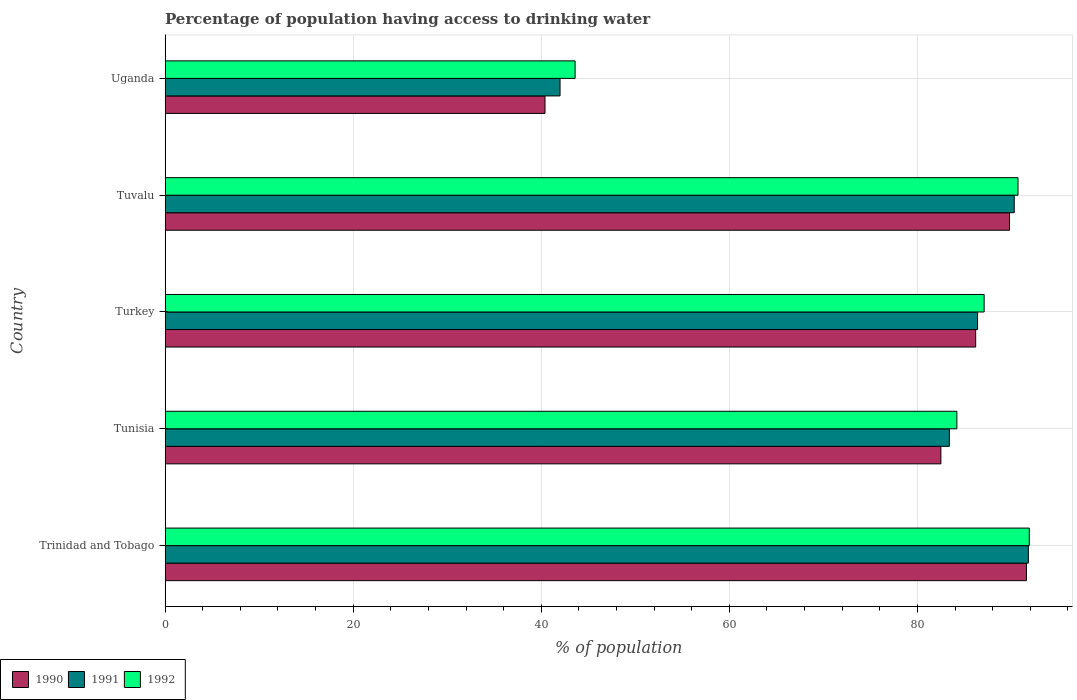How many groups of bars are there?
Give a very brief answer. 5. Are the number of bars on each tick of the Y-axis equal?
Your answer should be compact. Yes. How many bars are there on the 1st tick from the bottom?
Provide a succinct answer. 3. What is the label of the 2nd group of bars from the top?
Offer a terse response. Tuvalu. What is the percentage of population having access to drinking water in 1991 in Trinidad and Tobago?
Your answer should be very brief. 91.8. Across all countries, what is the maximum percentage of population having access to drinking water in 1990?
Your response must be concise. 91.6. In which country was the percentage of population having access to drinking water in 1992 maximum?
Give a very brief answer. Trinidad and Tobago. In which country was the percentage of population having access to drinking water in 1990 minimum?
Your answer should be very brief. Uganda. What is the total percentage of population having access to drinking water in 1992 in the graph?
Offer a very short reply. 397.5. What is the difference between the percentage of population having access to drinking water in 1990 in Tunisia and that in Turkey?
Make the answer very short. -3.7. What is the difference between the percentage of population having access to drinking water in 1990 in Uganda and the percentage of population having access to drinking water in 1992 in Turkey?
Make the answer very short. -46.7. What is the average percentage of population having access to drinking water in 1991 per country?
Give a very brief answer. 78.78. What is the difference between the percentage of population having access to drinking water in 1991 and percentage of population having access to drinking water in 1990 in Tunisia?
Provide a short and direct response. 0.9. In how many countries, is the percentage of population having access to drinking water in 1991 greater than 16 %?
Offer a very short reply. 5. What is the ratio of the percentage of population having access to drinking water in 1990 in Trinidad and Tobago to that in Tuvalu?
Give a very brief answer. 1.02. Is the difference between the percentage of population having access to drinking water in 1991 in Trinidad and Tobago and Uganda greater than the difference between the percentage of population having access to drinking water in 1990 in Trinidad and Tobago and Uganda?
Your response must be concise. No. What is the difference between the highest and the second highest percentage of population having access to drinking water in 1990?
Make the answer very short. 1.8. What is the difference between the highest and the lowest percentage of population having access to drinking water in 1992?
Ensure brevity in your answer.  48.3. In how many countries, is the percentage of population having access to drinking water in 1991 greater than the average percentage of population having access to drinking water in 1991 taken over all countries?
Your response must be concise. 4. How many bars are there?
Keep it short and to the point. 15. Does the graph contain any zero values?
Your answer should be compact. No. Does the graph contain grids?
Your answer should be very brief. Yes. What is the title of the graph?
Your answer should be compact. Percentage of population having access to drinking water. Does "1980" appear as one of the legend labels in the graph?
Your answer should be compact. No. What is the label or title of the X-axis?
Offer a very short reply. % of population. What is the label or title of the Y-axis?
Provide a succinct answer. Country. What is the % of population in 1990 in Trinidad and Tobago?
Ensure brevity in your answer.  91.6. What is the % of population of 1991 in Trinidad and Tobago?
Provide a succinct answer. 91.8. What is the % of population in 1992 in Trinidad and Tobago?
Your response must be concise. 91.9. What is the % of population of 1990 in Tunisia?
Your response must be concise. 82.5. What is the % of population of 1991 in Tunisia?
Offer a terse response. 83.4. What is the % of population in 1992 in Tunisia?
Your answer should be very brief. 84.2. What is the % of population of 1990 in Turkey?
Your answer should be very brief. 86.2. What is the % of population in 1991 in Turkey?
Give a very brief answer. 86.4. What is the % of population of 1992 in Turkey?
Give a very brief answer. 87.1. What is the % of population of 1990 in Tuvalu?
Keep it short and to the point. 89.8. What is the % of population in 1991 in Tuvalu?
Make the answer very short. 90.3. What is the % of population in 1992 in Tuvalu?
Provide a succinct answer. 90.7. What is the % of population in 1990 in Uganda?
Keep it short and to the point. 40.4. What is the % of population in 1991 in Uganda?
Offer a very short reply. 42. What is the % of population of 1992 in Uganda?
Ensure brevity in your answer.  43.6. Across all countries, what is the maximum % of population in 1990?
Provide a succinct answer. 91.6. Across all countries, what is the maximum % of population in 1991?
Your answer should be compact. 91.8. Across all countries, what is the maximum % of population in 1992?
Your response must be concise. 91.9. Across all countries, what is the minimum % of population of 1990?
Keep it short and to the point. 40.4. Across all countries, what is the minimum % of population in 1991?
Ensure brevity in your answer.  42. Across all countries, what is the minimum % of population in 1992?
Provide a succinct answer. 43.6. What is the total % of population of 1990 in the graph?
Keep it short and to the point. 390.5. What is the total % of population of 1991 in the graph?
Ensure brevity in your answer.  393.9. What is the total % of population of 1992 in the graph?
Your response must be concise. 397.5. What is the difference between the % of population in 1992 in Trinidad and Tobago and that in Tunisia?
Provide a succinct answer. 7.7. What is the difference between the % of population of 1991 in Trinidad and Tobago and that in Turkey?
Your answer should be compact. 5.4. What is the difference between the % of population in 1992 in Trinidad and Tobago and that in Tuvalu?
Offer a terse response. 1.2. What is the difference between the % of population of 1990 in Trinidad and Tobago and that in Uganda?
Give a very brief answer. 51.2. What is the difference between the % of population of 1991 in Trinidad and Tobago and that in Uganda?
Ensure brevity in your answer.  49.8. What is the difference between the % of population of 1992 in Trinidad and Tobago and that in Uganda?
Make the answer very short. 48.3. What is the difference between the % of population in 1991 in Tunisia and that in Turkey?
Provide a short and direct response. -3. What is the difference between the % of population of 1990 in Tunisia and that in Tuvalu?
Offer a terse response. -7.3. What is the difference between the % of population of 1990 in Tunisia and that in Uganda?
Make the answer very short. 42.1. What is the difference between the % of population of 1991 in Tunisia and that in Uganda?
Your response must be concise. 41.4. What is the difference between the % of population of 1992 in Tunisia and that in Uganda?
Your answer should be compact. 40.6. What is the difference between the % of population in 1991 in Turkey and that in Tuvalu?
Your answer should be very brief. -3.9. What is the difference between the % of population of 1992 in Turkey and that in Tuvalu?
Make the answer very short. -3.6. What is the difference between the % of population in 1990 in Turkey and that in Uganda?
Provide a succinct answer. 45.8. What is the difference between the % of population of 1991 in Turkey and that in Uganda?
Your answer should be compact. 44.4. What is the difference between the % of population in 1992 in Turkey and that in Uganda?
Your answer should be compact. 43.5. What is the difference between the % of population of 1990 in Tuvalu and that in Uganda?
Your answer should be compact. 49.4. What is the difference between the % of population of 1991 in Tuvalu and that in Uganda?
Ensure brevity in your answer.  48.3. What is the difference between the % of population of 1992 in Tuvalu and that in Uganda?
Provide a short and direct response. 47.1. What is the difference between the % of population in 1990 in Trinidad and Tobago and the % of population in 1991 in Tunisia?
Your response must be concise. 8.2. What is the difference between the % of population of 1991 in Trinidad and Tobago and the % of population of 1992 in Tunisia?
Make the answer very short. 7.6. What is the difference between the % of population of 1990 in Trinidad and Tobago and the % of population of 1991 in Uganda?
Keep it short and to the point. 49.6. What is the difference between the % of population of 1991 in Trinidad and Tobago and the % of population of 1992 in Uganda?
Make the answer very short. 48.2. What is the difference between the % of population in 1990 in Tunisia and the % of population in 1991 in Uganda?
Your answer should be very brief. 40.5. What is the difference between the % of population in 1990 in Tunisia and the % of population in 1992 in Uganda?
Offer a very short reply. 38.9. What is the difference between the % of population of 1991 in Tunisia and the % of population of 1992 in Uganda?
Offer a terse response. 39.8. What is the difference between the % of population in 1990 in Turkey and the % of population in 1991 in Uganda?
Your response must be concise. 44.2. What is the difference between the % of population in 1990 in Turkey and the % of population in 1992 in Uganda?
Keep it short and to the point. 42.6. What is the difference between the % of population in 1991 in Turkey and the % of population in 1992 in Uganda?
Your response must be concise. 42.8. What is the difference between the % of population of 1990 in Tuvalu and the % of population of 1991 in Uganda?
Your answer should be compact. 47.8. What is the difference between the % of population in 1990 in Tuvalu and the % of population in 1992 in Uganda?
Your answer should be compact. 46.2. What is the difference between the % of population in 1991 in Tuvalu and the % of population in 1992 in Uganda?
Keep it short and to the point. 46.7. What is the average % of population in 1990 per country?
Offer a very short reply. 78.1. What is the average % of population of 1991 per country?
Your answer should be compact. 78.78. What is the average % of population of 1992 per country?
Make the answer very short. 79.5. What is the difference between the % of population of 1991 and % of population of 1992 in Tunisia?
Keep it short and to the point. -0.8. What is the difference between the % of population in 1990 and % of population in 1991 in Turkey?
Provide a succinct answer. -0.2. What is the difference between the % of population in 1990 and % of population in 1992 in Turkey?
Make the answer very short. -0.9. What is the difference between the % of population in 1990 and % of population in 1992 in Tuvalu?
Offer a very short reply. -0.9. What is the difference between the % of population of 1990 and % of population of 1991 in Uganda?
Your answer should be very brief. -1.6. What is the ratio of the % of population in 1990 in Trinidad and Tobago to that in Tunisia?
Your answer should be very brief. 1.11. What is the ratio of the % of population of 1991 in Trinidad and Tobago to that in Tunisia?
Your answer should be compact. 1.1. What is the ratio of the % of population of 1992 in Trinidad and Tobago to that in Tunisia?
Give a very brief answer. 1.09. What is the ratio of the % of population of 1990 in Trinidad and Tobago to that in Turkey?
Keep it short and to the point. 1.06. What is the ratio of the % of population in 1991 in Trinidad and Tobago to that in Turkey?
Make the answer very short. 1.06. What is the ratio of the % of population of 1992 in Trinidad and Tobago to that in Turkey?
Give a very brief answer. 1.06. What is the ratio of the % of population of 1990 in Trinidad and Tobago to that in Tuvalu?
Make the answer very short. 1.02. What is the ratio of the % of population of 1991 in Trinidad and Tobago to that in Tuvalu?
Give a very brief answer. 1.02. What is the ratio of the % of population of 1992 in Trinidad and Tobago to that in Tuvalu?
Provide a succinct answer. 1.01. What is the ratio of the % of population of 1990 in Trinidad and Tobago to that in Uganda?
Provide a succinct answer. 2.27. What is the ratio of the % of population of 1991 in Trinidad and Tobago to that in Uganda?
Ensure brevity in your answer.  2.19. What is the ratio of the % of population of 1992 in Trinidad and Tobago to that in Uganda?
Provide a short and direct response. 2.11. What is the ratio of the % of population in 1990 in Tunisia to that in Turkey?
Make the answer very short. 0.96. What is the ratio of the % of population of 1991 in Tunisia to that in Turkey?
Ensure brevity in your answer.  0.97. What is the ratio of the % of population in 1992 in Tunisia to that in Turkey?
Offer a terse response. 0.97. What is the ratio of the % of population of 1990 in Tunisia to that in Tuvalu?
Ensure brevity in your answer.  0.92. What is the ratio of the % of population of 1991 in Tunisia to that in Tuvalu?
Offer a terse response. 0.92. What is the ratio of the % of population of 1992 in Tunisia to that in Tuvalu?
Offer a terse response. 0.93. What is the ratio of the % of population of 1990 in Tunisia to that in Uganda?
Ensure brevity in your answer.  2.04. What is the ratio of the % of population in 1991 in Tunisia to that in Uganda?
Offer a very short reply. 1.99. What is the ratio of the % of population in 1992 in Tunisia to that in Uganda?
Offer a very short reply. 1.93. What is the ratio of the % of population of 1990 in Turkey to that in Tuvalu?
Ensure brevity in your answer.  0.96. What is the ratio of the % of population in 1991 in Turkey to that in Tuvalu?
Give a very brief answer. 0.96. What is the ratio of the % of population in 1992 in Turkey to that in Tuvalu?
Offer a very short reply. 0.96. What is the ratio of the % of population of 1990 in Turkey to that in Uganda?
Give a very brief answer. 2.13. What is the ratio of the % of population of 1991 in Turkey to that in Uganda?
Ensure brevity in your answer.  2.06. What is the ratio of the % of population of 1992 in Turkey to that in Uganda?
Ensure brevity in your answer.  2. What is the ratio of the % of population in 1990 in Tuvalu to that in Uganda?
Your answer should be compact. 2.22. What is the ratio of the % of population in 1991 in Tuvalu to that in Uganda?
Provide a succinct answer. 2.15. What is the ratio of the % of population in 1992 in Tuvalu to that in Uganda?
Offer a terse response. 2.08. What is the difference between the highest and the second highest % of population in 1991?
Keep it short and to the point. 1.5. What is the difference between the highest and the second highest % of population in 1992?
Offer a terse response. 1.2. What is the difference between the highest and the lowest % of population of 1990?
Your answer should be very brief. 51.2. What is the difference between the highest and the lowest % of population of 1991?
Your response must be concise. 49.8. What is the difference between the highest and the lowest % of population in 1992?
Your response must be concise. 48.3. 